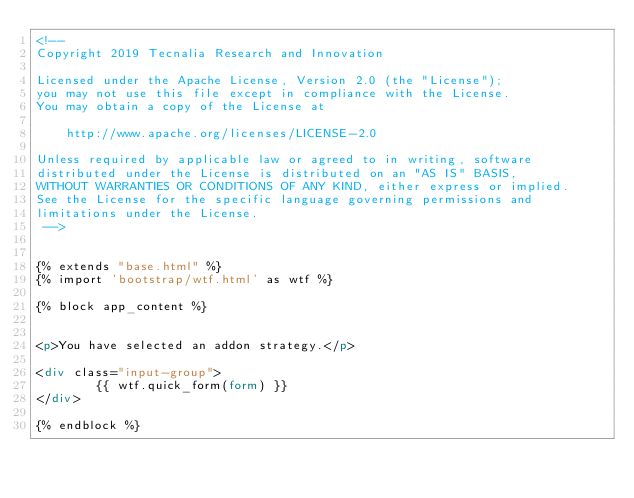<code> <loc_0><loc_0><loc_500><loc_500><_HTML_><!--
Copyright 2019 Tecnalia Research and Innovation

Licensed under the Apache License, Version 2.0 (the "License");
you may not use this file except in compliance with the License.
You may obtain a copy of the License at

    http://www.apache.org/licenses/LICENSE-2.0

Unless required by applicable law or agreed to in writing, software
distributed under the License is distributed on an "AS IS" BASIS,
WITHOUT WARRANTIES OR CONDITIONS OF ANY KIND, either express or implied.
See the License for the specific language governing permissions and
limitations under the License.
 -->


{% extends "base.html" %}
{% import 'bootstrap/wtf.html' as wtf %}

{% block app_content %}


<p>You have selected an addon strategy.</p>

<div class="input-group">
        {{ wtf.quick_form(form) }}
</div>

{% endblock %}</code> 